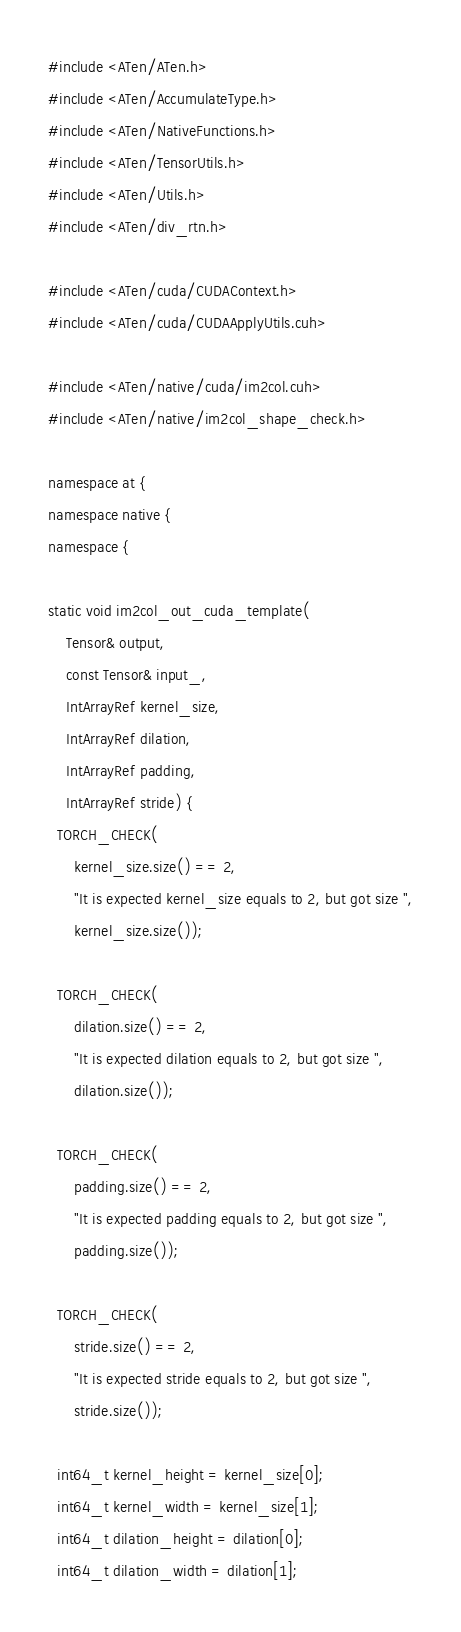Convert code to text. <code><loc_0><loc_0><loc_500><loc_500><_Cuda_>#include <ATen/ATen.h>
#include <ATen/AccumulateType.h>
#include <ATen/NativeFunctions.h>
#include <ATen/TensorUtils.h>
#include <ATen/Utils.h>
#include <ATen/div_rtn.h>

#include <ATen/cuda/CUDAContext.h>
#include <ATen/cuda/CUDAApplyUtils.cuh>

#include <ATen/native/cuda/im2col.cuh>
#include <ATen/native/im2col_shape_check.h>

namespace at {
namespace native {
namespace {

static void im2col_out_cuda_template(
    Tensor& output,
    const Tensor& input_,
    IntArrayRef kernel_size,
    IntArrayRef dilation,
    IntArrayRef padding,
    IntArrayRef stride) {
  TORCH_CHECK(
      kernel_size.size() == 2,
      "It is expected kernel_size equals to 2, but got size ",
      kernel_size.size());

  TORCH_CHECK(
      dilation.size() == 2,
      "It is expected dilation equals to 2, but got size ",
      dilation.size());

  TORCH_CHECK(
      padding.size() == 2,
      "It is expected padding equals to 2, but got size ",
      padding.size());

  TORCH_CHECK(
      stride.size() == 2,
      "It is expected stride equals to 2, but got size ",
      stride.size());

  int64_t kernel_height = kernel_size[0];
  int64_t kernel_width = kernel_size[1];
  int64_t dilation_height = dilation[0];
  int64_t dilation_width = dilation[1];</code> 